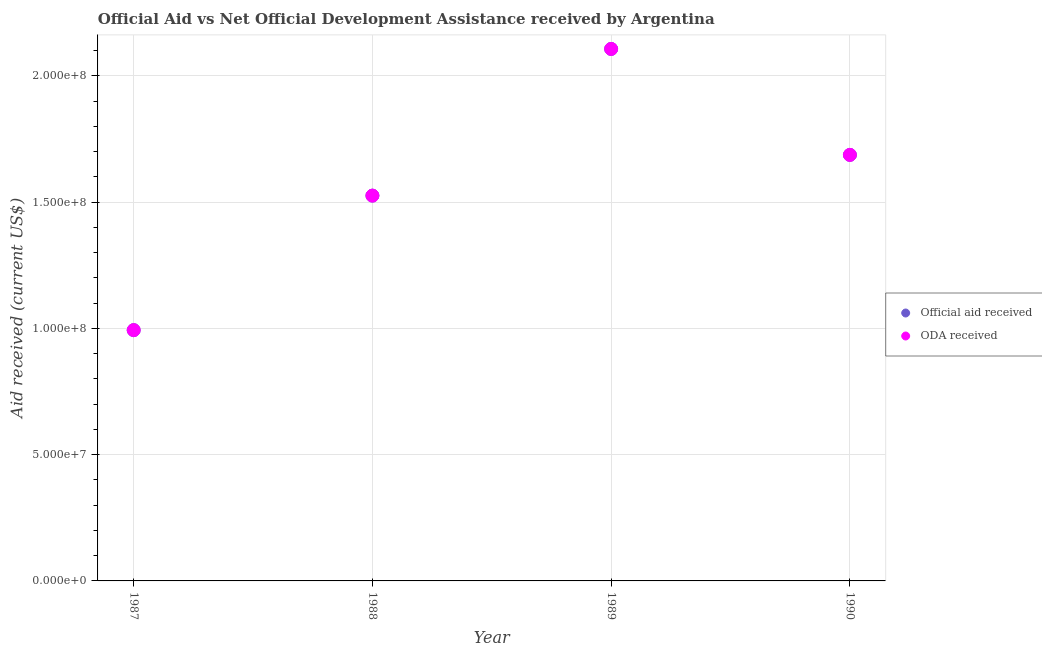How many different coloured dotlines are there?
Your answer should be very brief. 2. Is the number of dotlines equal to the number of legend labels?
Ensure brevity in your answer.  Yes. What is the oda received in 1988?
Provide a succinct answer. 1.53e+08. Across all years, what is the maximum official aid received?
Ensure brevity in your answer.  2.11e+08. Across all years, what is the minimum official aid received?
Keep it short and to the point. 9.93e+07. In which year was the oda received minimum?
Keep it short and to the point. 1987. What is the total official aid received in the graph?
Your answer should be compact. 6.31e+08. What is the difference between the official aid received in 1987 and that in 1990?
Offer a terse response. -6.94e+07. What is the difference between the oda received in 1987 and the official aid received in 1988?
Ensure brevity in your answer.  -5.33e+07. What is the average official aid received per year?
Offer a terse response. 1.58e+08. In how many years, is the official aid received greater than 150000000 US$?
Offer a terse response. 3. What is the ratio of the official aid received in 1989 to that in 1990?
Offer a terse response. 1.25. Is the difference between the official aid received in 1987 and 1989 greater than the difference between the oda received in 1987 and 1989?
Ensure brevity in your answer.  No. What is the difference between the highest and the second highest oda received?
Provide a succinct answer. 4.20e+07. What is the difference between the highest and the lowest official aid received?
Make the answer very short. 1.11e+08. Is the sum of the official aid received in 1988 and 1989 greater than the maximum oda received across all years?
Your response must be concise. Yes. Does the official aid received monotonically increase over the years?
Your response must be concise. No. Is the official aid received strictly greater than the oda received over the years?
Your answer should be compact. No. Is the oda received strictly less than the official aid received over the years?
Make the answer very short. No. How many dotlines are there?
Your answer should be compact. 2. What is the difference between two consecutive major ticks on the Y-axis?
Offer a terse response. 5.00e+07. What is the title of the graph?
Ensure brevity in your answer.  Official Aid vs Net Official Development Assistance received by Argentina . What is the label or title of the Y-axis?
Make the answer very short. Aid received (current US$). What is the Aid received (current US$) in Official aid received in 1987?
Give a very brief answer. 9.93e+07. What is the Aid received (current US$) of ODA received in 1987?
Provide a short and direct response. 9.93e+07. What is the Aid received (current US$) in Official aid received in 1988?
Ensure brevity in your answer.  1.53e+08. What is the Aid received (current US$) of ODA received in 1988?
Provide a short and direct response. 1.53e+08. What is the Aid received (current US$) of Official aid received in 1989?
Your answer should be very brief. 2.11e+08. What is the Aid received (current US$) in ODA received in 1989?
Give a very brief answer. 2.11e+08. What is the Aid received (current US$) in Official aid received in 1990?
Give a very brief answer. 1.69e+08. What is the Aid received (current US$) of ODA received in 1990?
Offer a very short reply. 1.69e+08. Across all years, what is the maximum Aid received (current US$) in Official aid received?
Your answer should be compact. 2.11e+08. Across all years, what is the maximum Aid received (current US$) of ODA received?
Offer a terse response. 2.11e+08. Across all years, what is the minimum Aid received (current US$) in Official aid received?
Provide a succinct answer. 9.93e+07. Across all years, what is the minimum Aid received (current US$) of ODA received?
Give a very brief answer. 9.93e+07. What is the total Aid received (current US$) of Official aid received in the graph?
Your answer should be very brief. 6.31e+08. What is the total Aid received (current US$) in ODA received in the graph?
Provide a short and direct response. 6.31e+08. What is the difference between the Aid received (current US$) of Official aid received in 1987 and that in 1988?
Ensure brevity in your answer.  -5.33e+07. What is the difference between the Aid received (current US$) in ODA received in 1987 and that in 1988?
Offer a terse response. -5.33e+07. What is the difference between the Aid received (current US$) in Official aid received in 1987 and that in 1989?
Offer a very short reply. -1.11e+08. What is the difference between the Aid received (current US$) in ODA received in 1987 and that in 1989?
Give a very brief answer. -1.11e+08. What is the difference between the Aid received (current US$) of Official aid received in 1987 and that in 1990?
Provide a succinct answer. -6.94e+07. What is the difference between the Aid received (current US$) of ODA received in 1987 and that in 1990?
Your answer should be very brief. -6.94e+07. What is the difference between the Aid received (current US$) of Official aid received in 1988 and that in 1989?
Give a very brief answer. -5.81e+07. What is the difference between the Aid received (current US$) in ODA received in 1988 and that in 1989?
Make the answer very short. -5.81e+07. What is the difference between the Aid received (current US$) of Official aid received in 1988 and that in 1990?
Provide a short and direct response. -1.61e+07. What is the difference between the Aid received (current US$) of ODA received in 1988 and that in 1990?
Give a very brief answer. -1.61e+07. What is the difference between the Aid received (current US$) of Official aid received in 1989 and that in 1990?
Offer a very short reply. 4.20e+07. What is the difference between the Aid received (current US$) in ODA received in 1989 and that in 1990?
Your answer should be very brief. 4.20e+07. What is the difference between the Aid received (current US$) in Official aid received in 1987 and the Aid received (current US$) in ODA received in 1988?
Your answer should be compact. -5.33e+07. What is the difference between the Aid received (current US$) in Official aid received in 1987 and the Aid received (current US$) in ODA received in 1989?
Your answer should be very brief. -1.11e+08. What is the difference between the Aid received (current US$) in Official aid received in 1987 and the Aid received (current US$) in ODA received in 1990?
Provide a succinct answer. -6.94e+07. What is the difference between the Aid received (current US$) in Official aid received in 1988 and the Aid received (current US$) in ODA received in 1989?
Offer a very short reply. -5.81e+07. What is the difference between the Aid received (current US$) in Official aid received in 1988 and the Aid received (current US$) in ODA received in 1990?
Ensure brevity in your answer.  -1.61e+07. What is the difference between the Aid received (current US$) in Official aid received in 1989 and the Aid received (current US$) in ODA received in 1990?
Ensure brevity in your answer.  4.20e+07. What is the average Aid received (current US$) of Official aid received per year?
Provide a succinct answer. 1.58e+08. What is the average Aid received (current US$) of ODA received per year?
Make the answer very short. 1.58e+08. In the year 1987, what is the difference between the Aid received (current US$) of Official aid received and Aid received (current US$) of ODA received?
Provide a succinct answer. 0. In the year 1989, what is the difference between the Aid received (current US$) of Official aid received and Aid received (current US$) of ODA received?
Provide a short and direct response. 0. In the year 1990, what is the difference between the Aid received (current US$) in Official aid received and Aid received (current US$) in ODA received?
Provide a succinct answer. 0. What is the ratio of the Aid received (current US$) in Official aid received in 1987 to that in 1988?
Offer a very short reply. 0.65. What is the ratio of the Aid received (current US$) in ODA received in 1987 to that in 1988?
Offer a terse response. 0.65. What is the ratio of the Aid received (current US$) in Official aid received in 1987 to that in 1989?
Offer a very short reply. 0.47. What is the ratio of the Aid received (current US$) in ODA received in 1987 to that in 1989?
Your answer should be very brief. 0.47. What is the ratio of the Aid received (current US$) in Official aid received in 1987 to that in 1990?
Offer a terse response. 0.59. What is the ratio of the Aid received (current US$) in ODA received in 1987 to that in 1990?
Provide a short and direct response. 0.59. What is the ratio of the Aid received (current US$) in Official aid received in 1988 to that in 1989?
Your answer should be compact. 0.72. What is the ratio of the Aid received (current US$) in ODA received in 1988 to that in 1989?
Offer a very short reply. 0.72. What is the ratio of the Aid received (current US$) of Official aid received in 1988 to that in 1990?
Your answer should be compact. 0.9. What is the ratio of the Aid received (current US$) in ODA received in 1988 to that in 1990?
Keep it short and to the point. 0.9. What is the ratio of the Aid received (current US$) of Official aid received in 1989 to that in 1990?
Provide a succinct answer. 1.25. What is the ratio of the Aid received (current US$) of ODA received in 1989 to that in 1990?
Keep it short and to the point. 1.25. What is the difference between the highest and the second highest Aid received (current US$) in Official aid received?
Offer a very short reply. 4.20e+07. What is the difference between the highest and the second highest Aid received (current US$) in ODA received?
Provide a short and direct response. 4.20e+07. What is the difference between the highest and the lowest Aid received (current US$) in Official aid received?
Keep it short and to the point. 1.11e+08. What is the difference between the highest and the lowest Aid received (current US$) of ODA received?
Provide a short and direct response. 1.11e+08. 